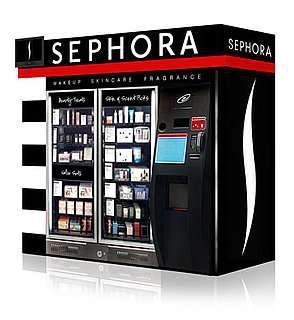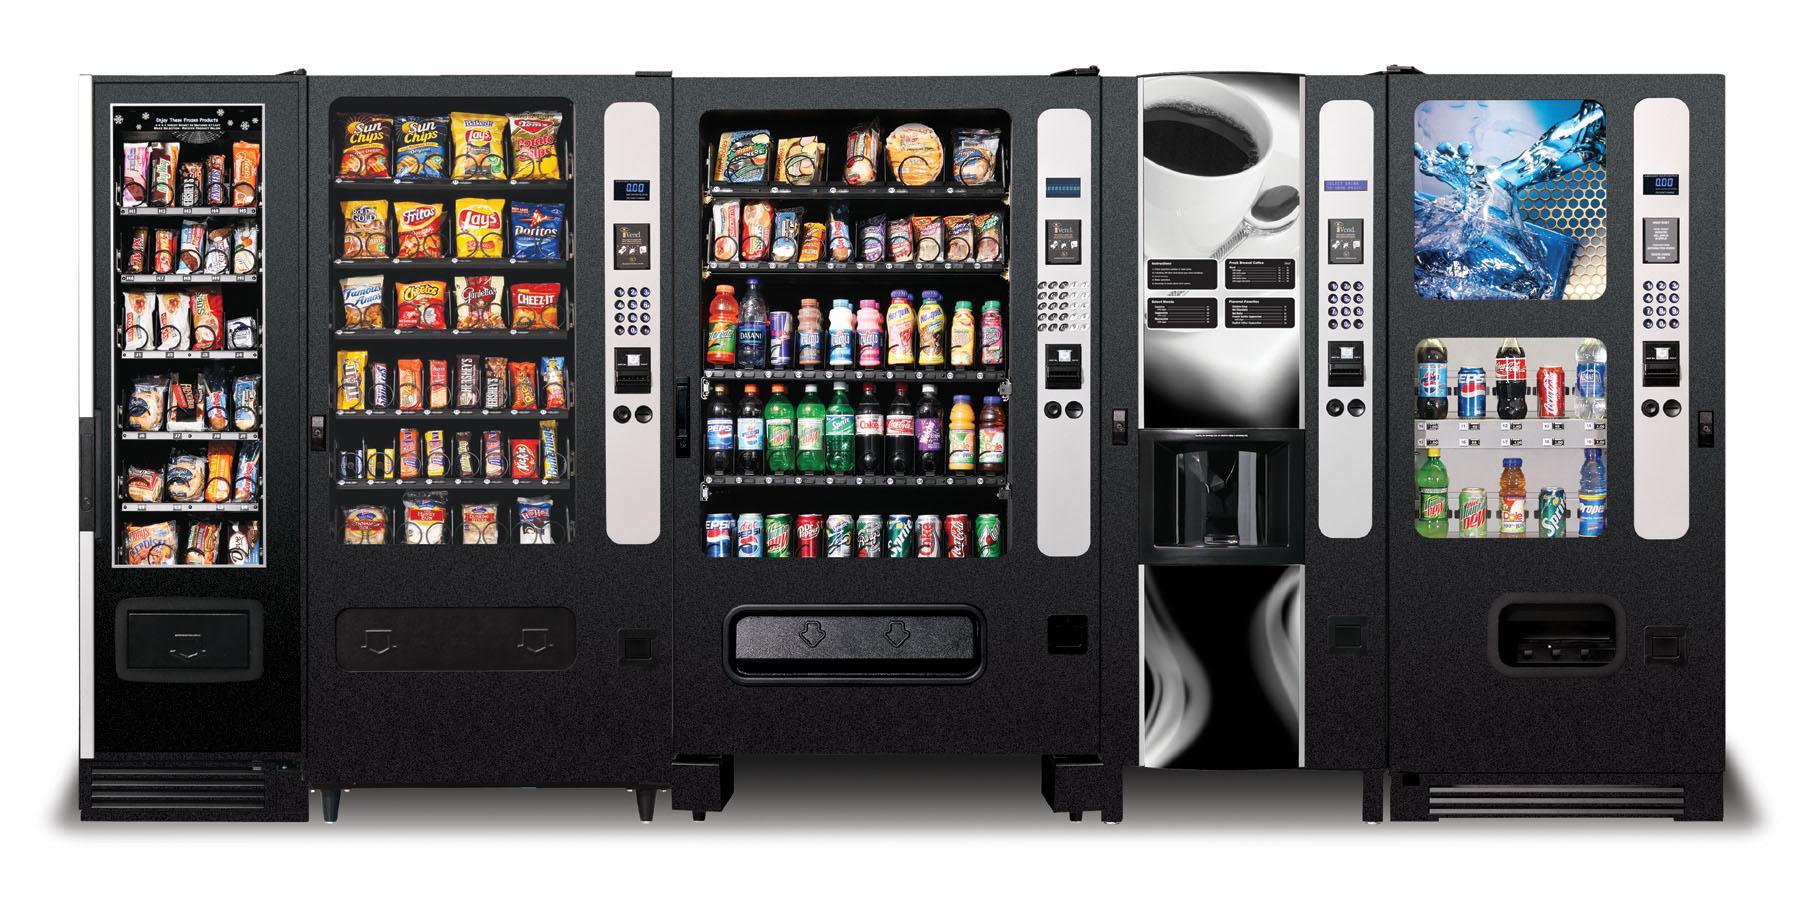The first image is the image on the left, the second image is the image on the right. Analyze the images presented: Is the assertion "There are at least three vending machines in the image on the right." valid? Answer yes or no. Yes. 